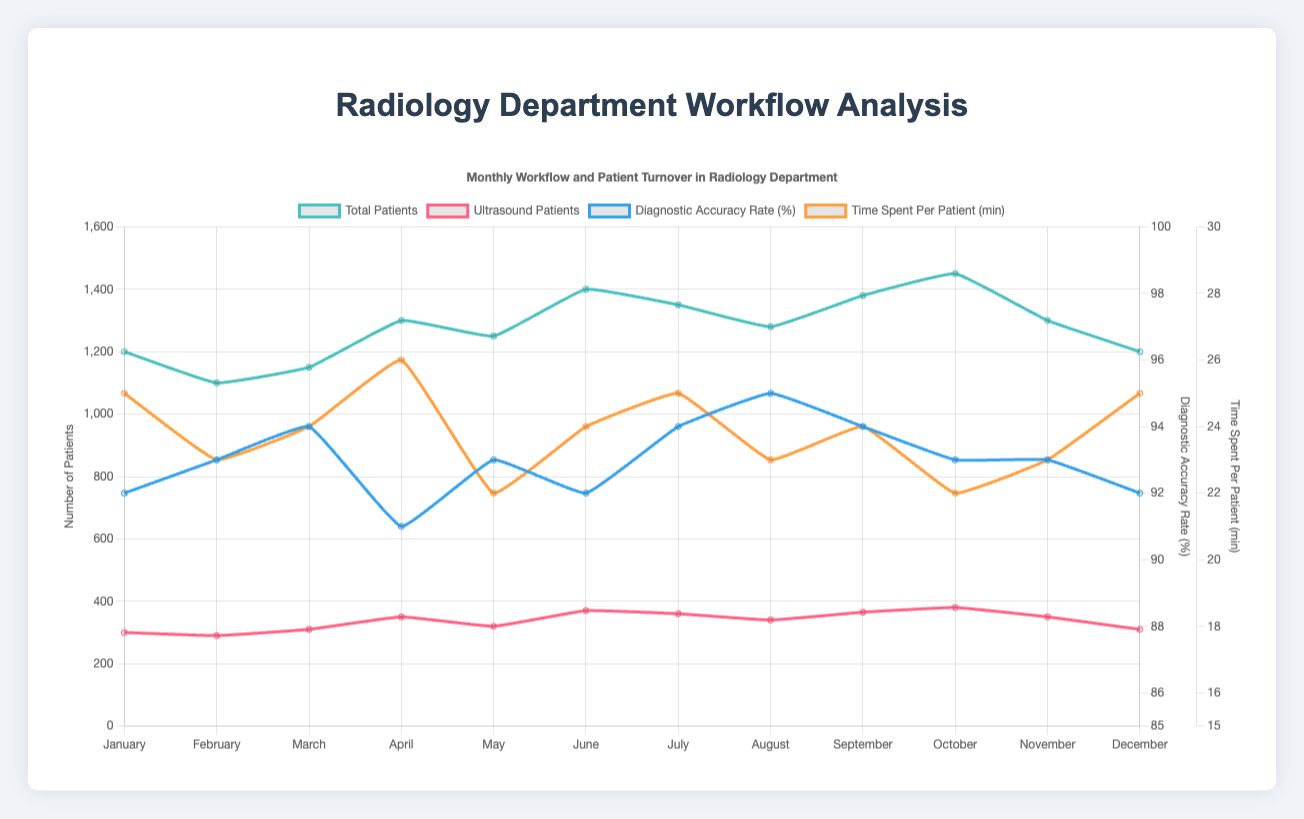What is the monthly trend of total patients in the radiology department? To find the trend of total patients, observe the line representing total patients across the months. Notice if it generally increases, decreases, or fluctuates.
Answer: Generally increasing with some fluctuations How does May compare to October in terms of total patients and ultrasound patients? Compare the total number of patients in May (1250) to October (1450), and the number of ultrasound patients in May (320) to October (380). May has fewer total and ultrasound patients than October.
Answer: May has fewer in both categories What month has the highest diagnostic accuracy rate and what is its value? Look for the peak point on the line representing diagnostic accuracy rate. The highest diagnostic accuracy is in August at 95%.
Answer: August, 95% What is the difference in the average time spent per patient between January and October? Compare the values for time spent per patient in January (25 minutes) with October (22 minutes). The difference is 25 - 22.
Answer: 3 minutes Describe the change in ultrasound patients from June to July. Observe the number of ultrasound patients in June (370) and July (360). The number decreased by 10 patients from June to July.
Answer: Decreases by 10 patients What is the cumulative total of patients in January and February? Add the number of total patients in January (1200) to those in February (1100).
Answer: 2300 Which month shows the highest number of ultrasound patients, and how does it compare to the total patients of the same month? Identify the month with the highest ultrasound patients (October with 380). Compare it to the total patients of the same month (1450).
Answer: October, 380 to 1450 How much greater is the total number of patients in June compared to February? Subtract the total number of patients in February (1100) from those in June (1400).
Answer: 300 In which month do we see the maximum time spent per patient, and what is this value? Find the month with the highest point on the line representing time spent per patient (April at 26 minutes).
Answer: April, 26 minutes What is the median diagnostic accuracy rate over the year? List all the accuracy rates and find the middle value. Accuracy rates are: 91, 92, 92, 92, 93, 93, 93, 94, 94, 94, 95. The median value is the middle in an ordered list, which is 93.
Answer: 93 